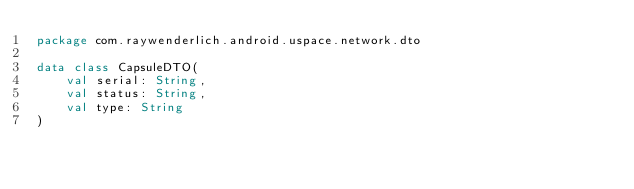Convert code to text. <code><loc_0><loc_0><loc_500><loc_500><_Kotlin_>package com.raywenderlich.android.uspace.network.dto

data class CapsuleDTO(
    val serial: String,
    val status: String,
    val type: String
)
</code> 